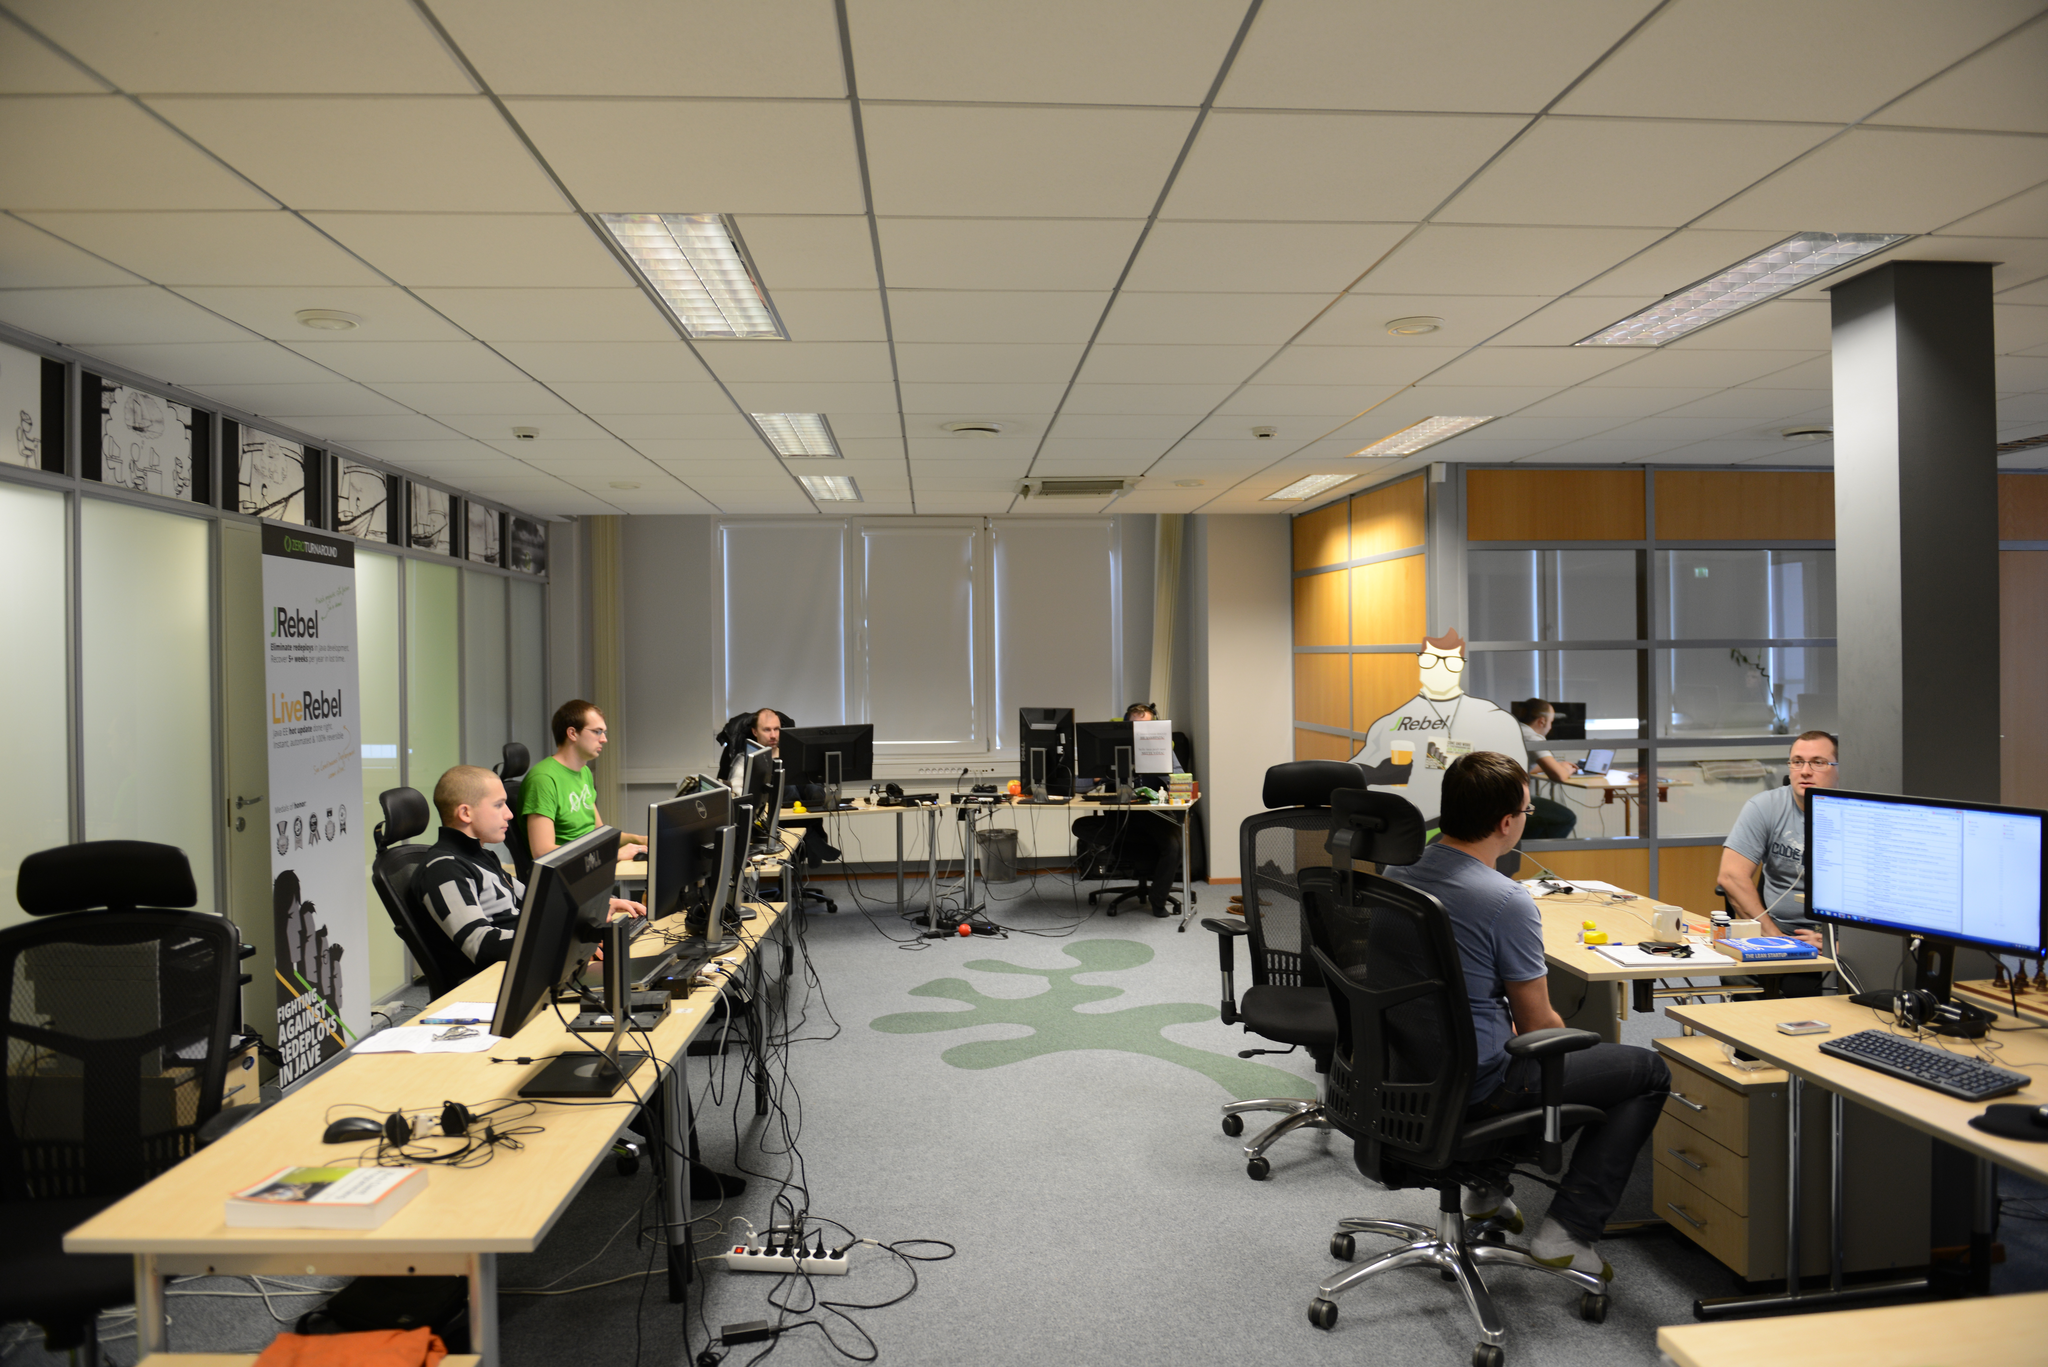Describe this image in one or two sentences. In this image we can see a few people who are sitting in front of a computer and they are working. 